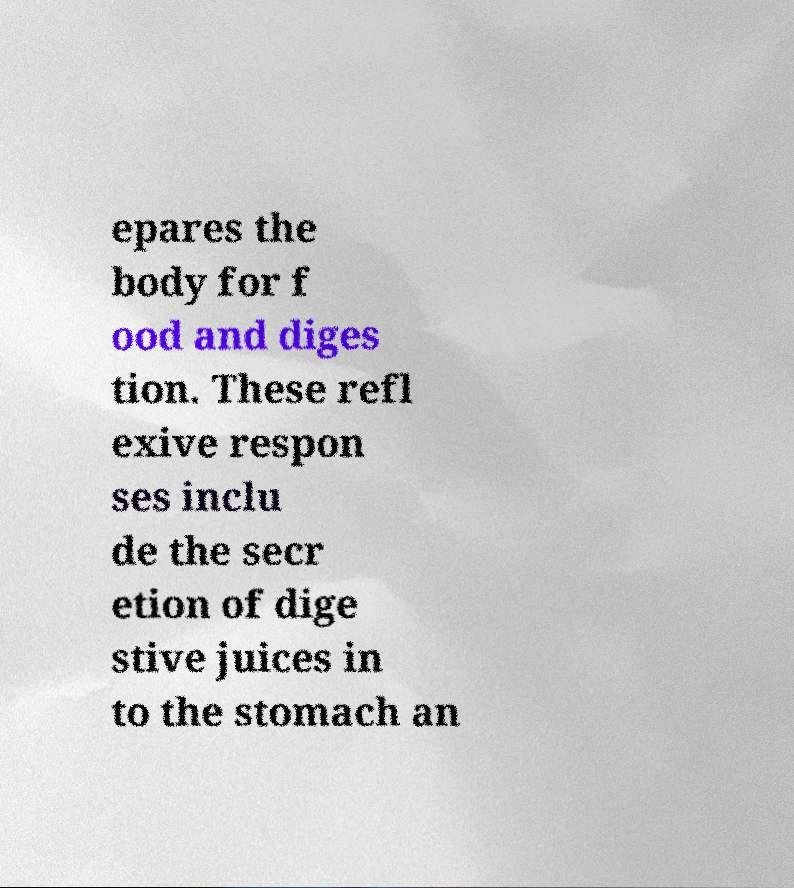For documentation purposes, I need the text within this image transcribed. Could you provide that? epares the body for f ood and diges tion. These refl exive respon ses inclu de the secr etion of dige stive juices in to the stomach an 